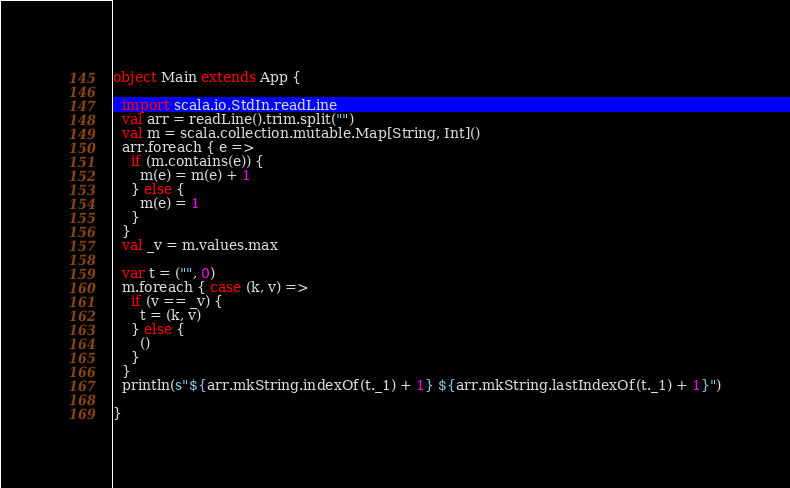<code> <loc_0><loc_0><loc_500><loc_500><_Scala_>object Main extends App {

  import scala.io.StdIn.readLine
  val arr = readLine().trim.split("")
  val m = scala.collection.mutable.Map[String, Int]()
  arr.foreach { e =>
    if (m.contains(e)) {
      m(e) = m(e) + 1
    } else {
      m(e) = 1
    }
  }
  val _v = m.values.max

  var t = ("", 0)
  m.foreach { case (k, v) =>
    if (v == _v) {
      t = (k, v)
    } else {
      ()
    }
  }
  println(s"${arr.mkString.indexOf(t._1) + 1} ${arr.mkString.lastIndexOf(t._1) + 1}")

}
</code> 